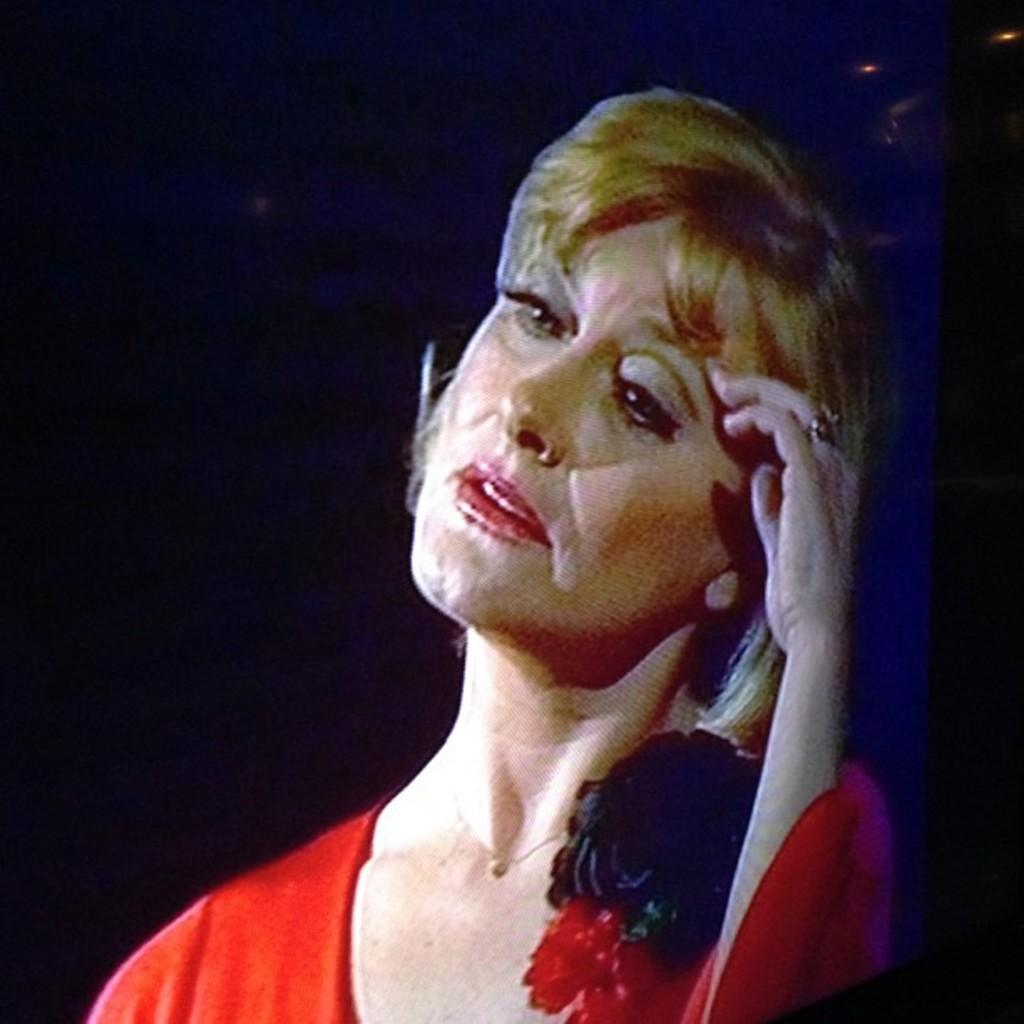Who is the main subject in the image? There is a woman in the image. What is the woman wearing? The woman is wearing an orange top. Can you describe any additional details about the woman's appearance? There is a black object on the woman's shoulder. What type of noise can be heard coming from the sea in the image? There is no sea present in the image, so it's not possible to determine what, if any, noise might be heard. 